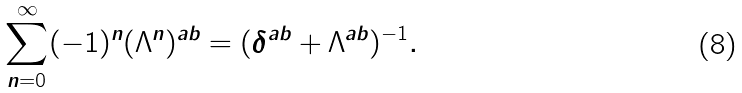Convert formula to latex. <formula><loc_0><loc_0><loc_500><loc_500>\sum _ { n = 0 } ^ { \infty } ( - 1 ) ^ { n } ( \Lambda ^ { n } ) ^ { a b } = ( \delta ^ { a b } + \Lambda ^ { a b } ) ^ { - 1 } .</formula> 